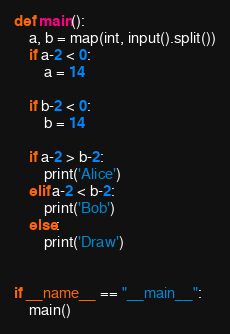Convert code to text. <code><loc_0><loc_0><loc_500><loc_500><_Python_>
def main():
    a, b = map(int, input().split())
    if a-2 < 0:
        a = 14

    if b-2 < 0:
        b = 14

    if a-2 > b-2:
        print('Alice')
    elif a-2 < b-2:
        print('Bob')
    else:
        print('Draw')


if __name__ == "__main__":
    main()

</code> 